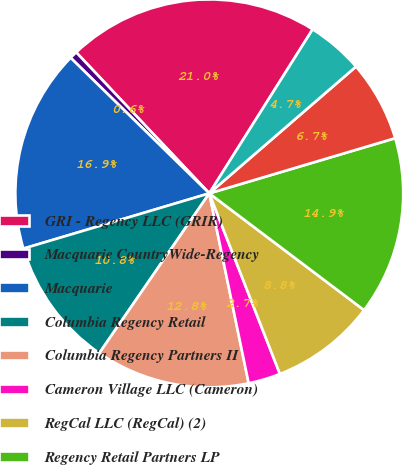<chart> <loc_0><loc_0><loc_500><loc_500><pie_chart><fcel>GRI - Regency LLC (GRIR)<fcel>Macquarie CountryWide-Regency<fcel>Macquarie<fcel>Columbia Regency Retail<fcel>Columbia Regency Partners II<fcel>Cameron Village LLC (Cameron)<fcel>RegCal LLC (RegCal) (2)<fcel>Regency Retail Partners LP<fcel>US Regency Retail I LLC (USAA)<fcel>Other investments in real<nl><fcel>20.99%<fcel>0.64%<fcel>16.92%<fcel>10.81%<fcel>12.85%<fcel>2.68%<fcel>8.78%<fcel>14.88%<fcel>6.75%<fcel>4.71%<nl></chart> 